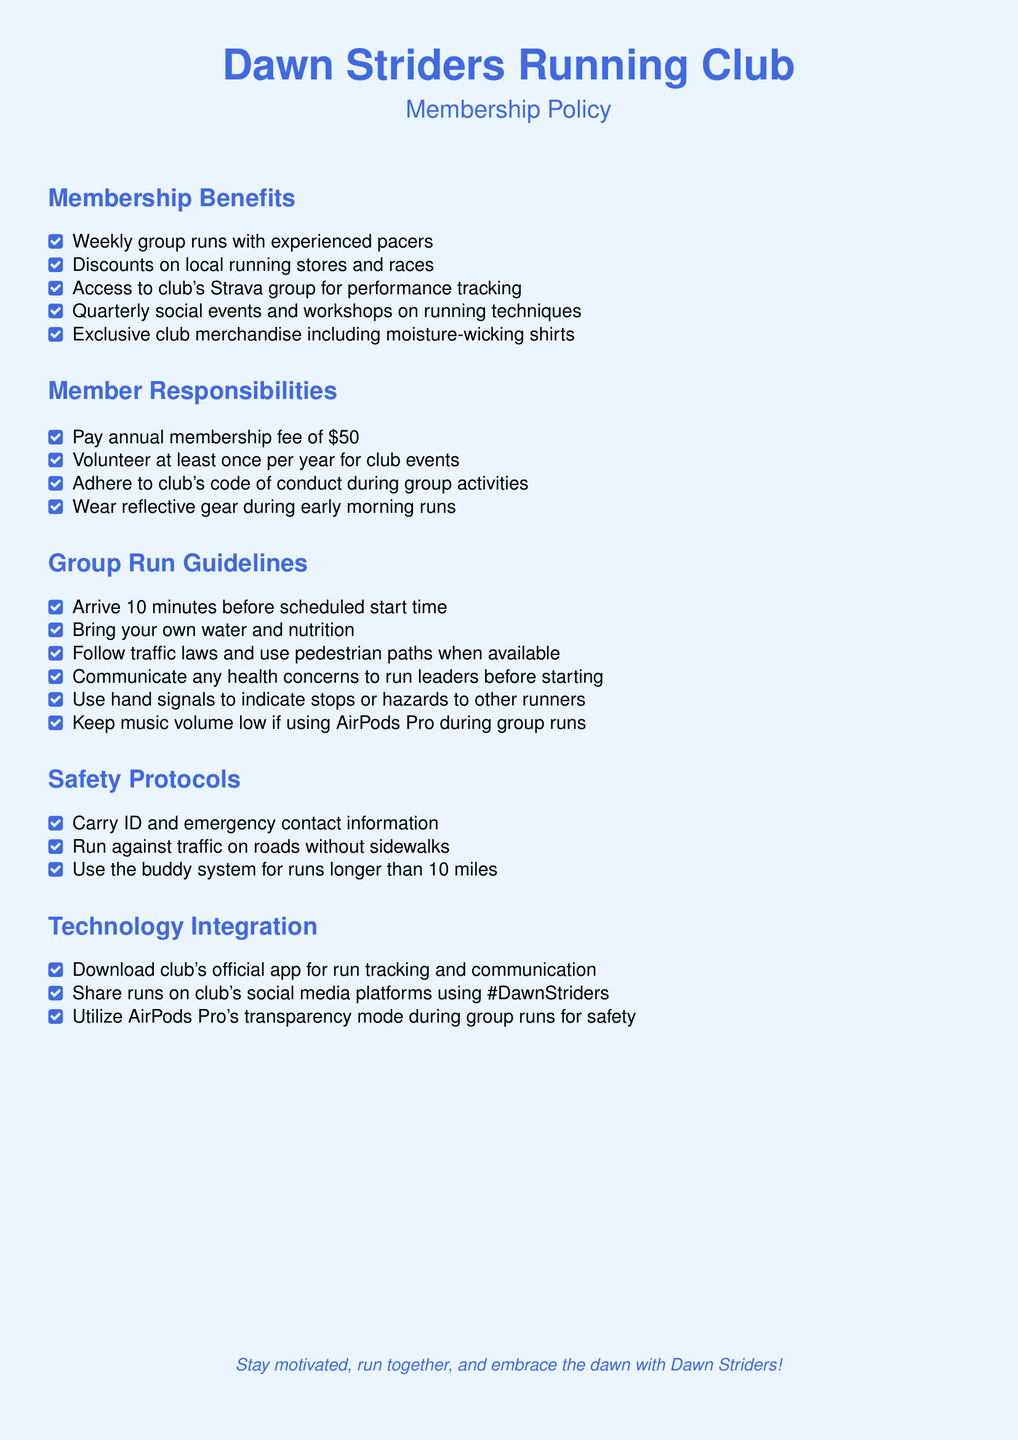What is the annual membership fee? The document states that the annual membership fee is $50.
Answer: $50 What benefits are provided by the club? The list of membership benefits includes five specific items.
Answer: Weekly group runs with experienced pacers, Discounts on local running stores and races, Access to club's Strava group for performance tracking, Quarterly social events and workshops on running techniques, Exclusive club merchandise How often must members volunteer? The document specifies that members must volunteer at least once per year.
Answer: Once per year What is required before starting a group run? Members are instructed to communicate any health concerns to run leaders before starting.
Answer: Health concerns How should members behave during group runs? Members must adhere to the club's code of conduct during group activities.
Answer: Adhere to code of conduct What should members wear during early morning runs? The responsibility outlined for members includes wearing reflective gear during early morning runs.
Answer: Reflective gear What is the maximum distance for using the buddy system? The document mentions the buddy system for runs longer than 10 miles.
Answer: 10 miles How can members share their runs on social media? The document suggests using the hashtag #DawnStriders when sharing runs on social platforms.
Answer: #DawnStriders What technology should members use for run tracking? The document advises downloading the club's official app for run tracking.
Answer: Club's official app 